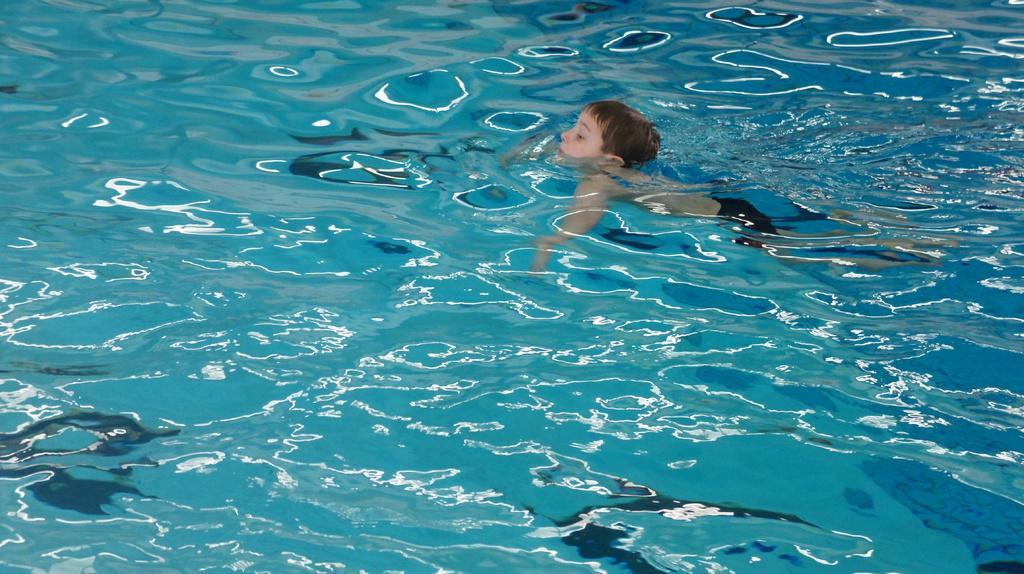Could you give a brief overview of what you see in this image? In this picture we can see a boy in the water. 